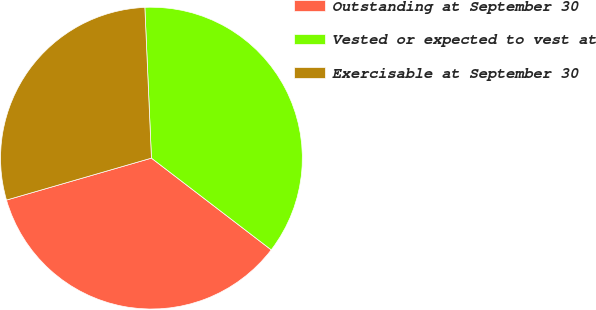Convert chart to OTSL. <chart><loc_0><loc_0><loc_500><loc_500><pie_chart><fcel>Outstanding at September 30<fcel>Vested or expected to vest at<fcel>Exercisable at September 30<nl><fcel>35.12%<fcel>36.1%<fcel>28.79%<nl></chart> 